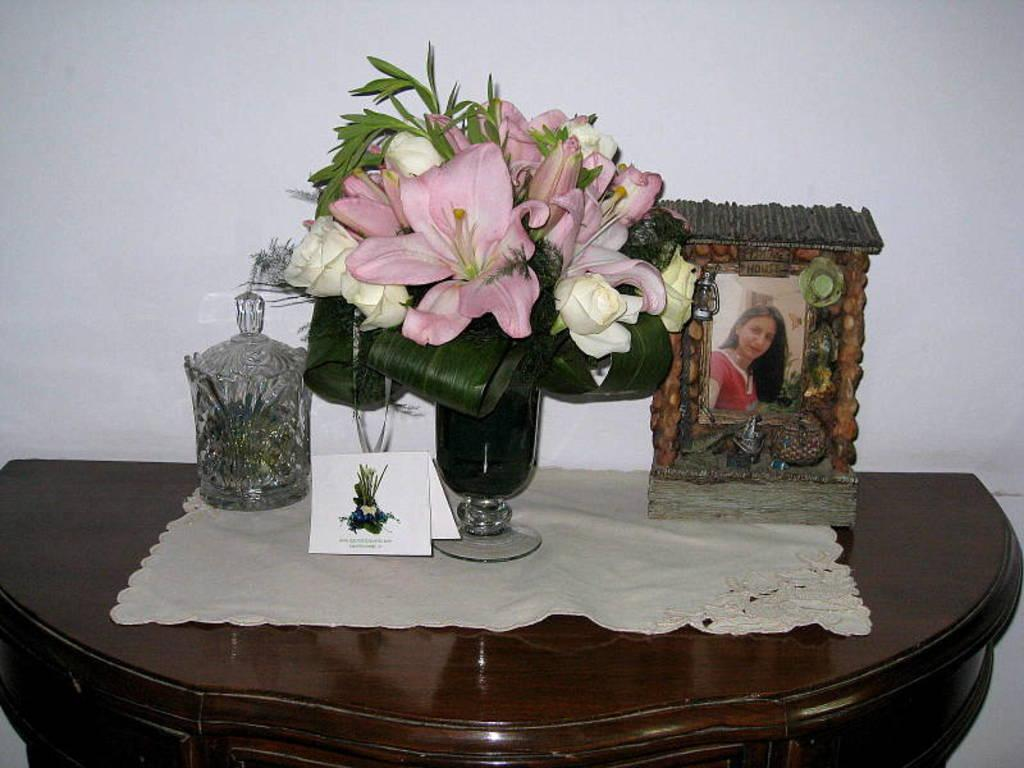What type of container is present in the image? There is a flower vase in the image. What other objects can be seen in the image? There is a jar, a card, a photo frame, and cloth in the image. What is the surface on which these objects are placed? The objects are placed on a wooden table. What can be seen in the background of the image? There is a white color wall in the background of the image. What month is depicted in the photo frame in the image? There is no photo frame in the image that shows a specific month. How does the plane in the image relate to the objects on the wooden table? There is no plane present in the image; it only features a flower vase, jar, card, photo frame, and cloth on a wooden table. 